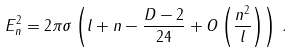<formula> <loc_0><loc_0><loc_500><loc_500>E _ { n } ^ { 2 } = 2 \pi \sigma \left ( l + n - \frac { D - 2 } { 2 4 } + O \left ( \frac { n ^ { 2 } } { l } \right ) \right ) \, .</formula> 